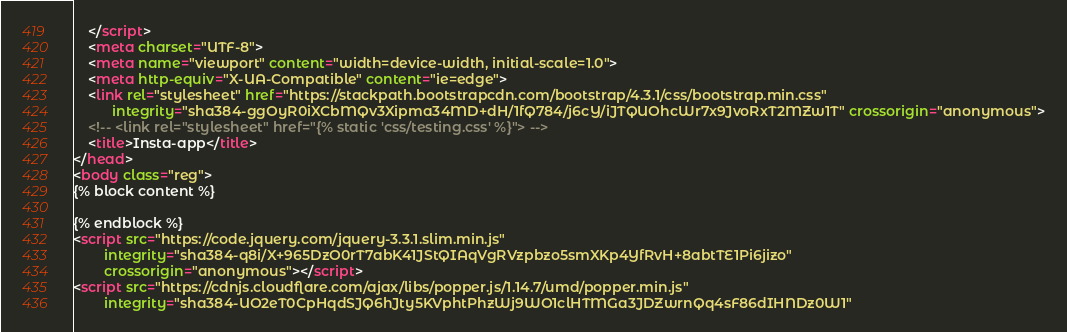Convert code to text. <code><loc_0><loc_0><loc_500><loc_500><_HTML_>    </script>
    <meta charset="UTF-8">
    <meta name="viewport" content="width=device-width, initial-scale=1.0">
    <meta http-equiv="X-UA-Compatible" content="ie=edge">
    <link rel="stylesheet" href="https://stackpath.bootstrapcdn.com/bootstrap/4.3.1/css/bootstrap.min.css"
          integrity="sha384-ggOyR0iXCbMQv3Xipma34MD+dH/1fQ784/j6cY/iJTQUOhcWr7x9JvoRxT2MZw1T" crossorigin="anonymous">
    <!-- <link rel="stylesheet" href="{% static 'css/testing.css' %}"> -->
    <title>Insta-app</title>
</head>
<body class="reg">
{% block content %}

{% endblock %}
<script src="https://code.jquery.com/jquery-3.3.1.slim.min.js"
        integrity="sha384-q8i/X+965DzO0rT7abK41JStQIAqVgRVzpbzo5smXKp4YfRvH+8abtTE1Pi6jizo"
        crossorigin="anonymous"></script>
<script src="https://cdnjs.cloudflare.com/ajax/libs/popper.js/1.14.7/umd/popper.min.js"
        integrity="sha384-UO2eT0CpHqdSJQ6hJty5KVphtPhzWj9WO1clHTMGa3JDZwrnQq4sF86dIHNDz0W1"</code> 